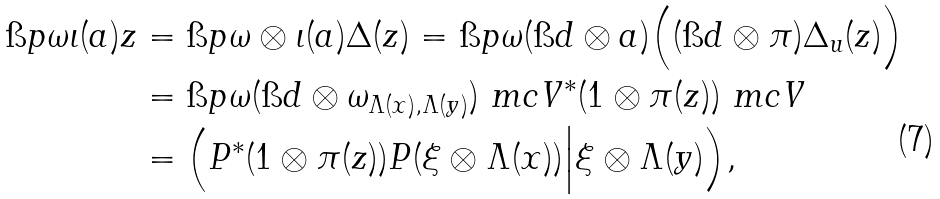Convert formula to latex. <formula><loc_0><loc_0><loc_500><loc_500>\i p { \omega \iota ( a ) } { z } & = \i p { \omega \otimes \iota ( a ) } { \Delta ( z ) } = \i p { \omega } { ( \i d \otimes a ) \Big ( ( \i d \otimes \pi ) \Delta _ { u } ( z ) \Big ) } \\ & = \i p { \omega } { ( \i d \otimes \omega _ { \Lambda ( x ) , \Lambda ( y ) } ) \ m c V ^ { * } ( 1 \otimes \pi ( z ) ) \ m c V } \\ & = \Big ( P ^ { * } ( 1 \otimes \pi ( z ) ) P ( \xi \otimes \Lambda ( x ) ) \Big | \xi \otimes \Lambda ( y ) \Big ) ,</formula> 